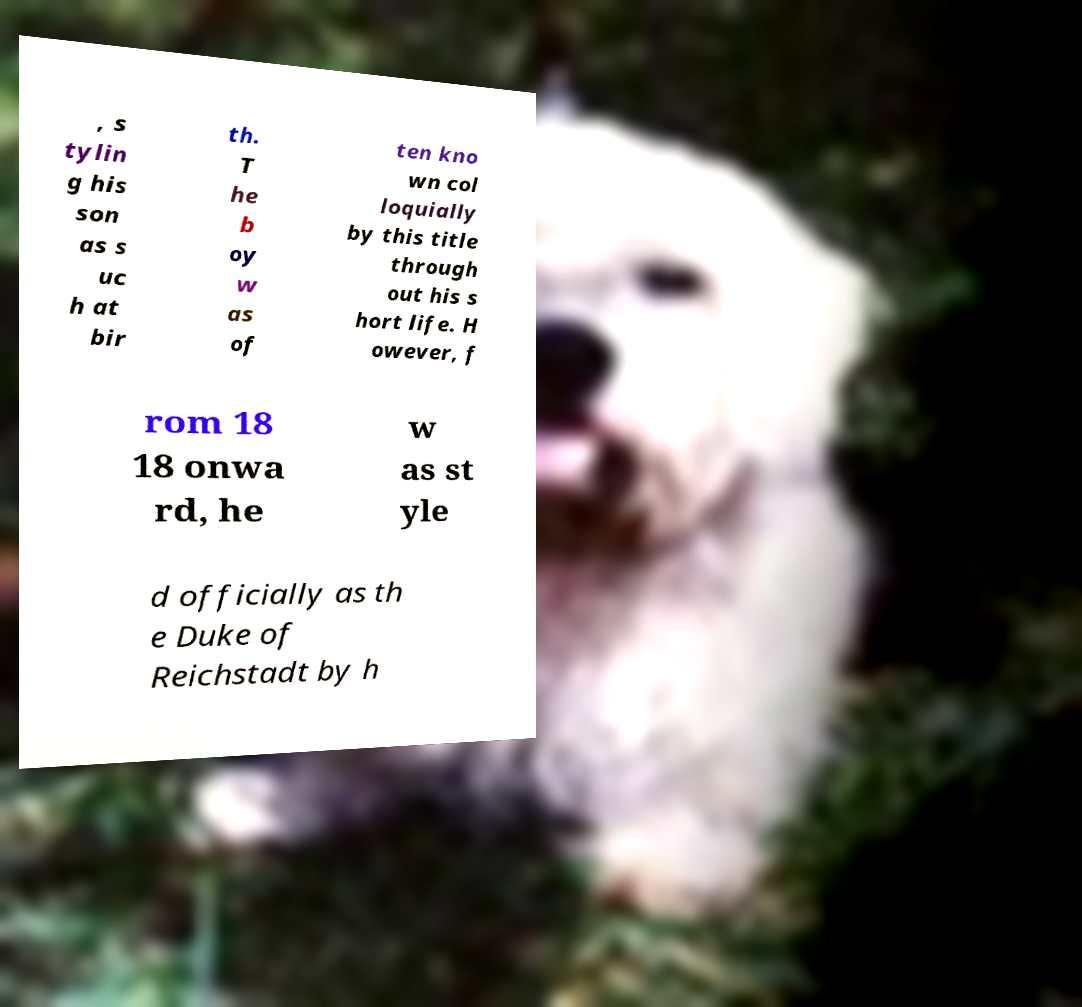I need the written content from this picture converted into text. Can you do that? , s tylin g his son as s uc h at bir th. T he b oy w as of ten kno wn col loquially by this title through out his s hort life. H owever, f rom 18 18 onwa rd, he w as st yle d officially as th e Duke of Reichstadt by h 